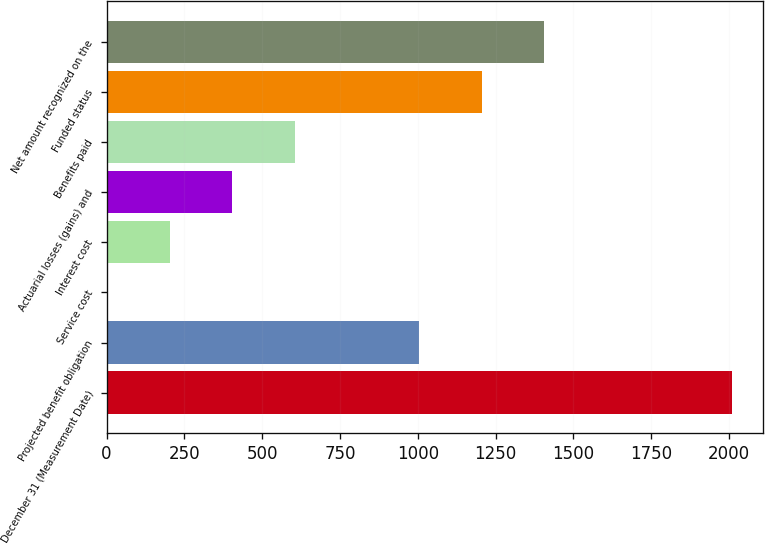Convert chart. <chart><loc_0><loc_0><loc_500><loc_500><bar_chart><fcel>December 31 (Measurement Date)<fcel>Projected benefit obligation<fcel>Service cost<fcel>Interest cost<fcel>Actuarial losses (gains) and<fcel>Benefits paid<fcel>Funded status<fcel>Net amount recognized on the<nl><fcel>2009<fcel>1005.5<fcel>2<fcel>202.7<fcel>403.4<fcel>604.1<fcel>1206.2<fcel>1406.9<nl></chart> 